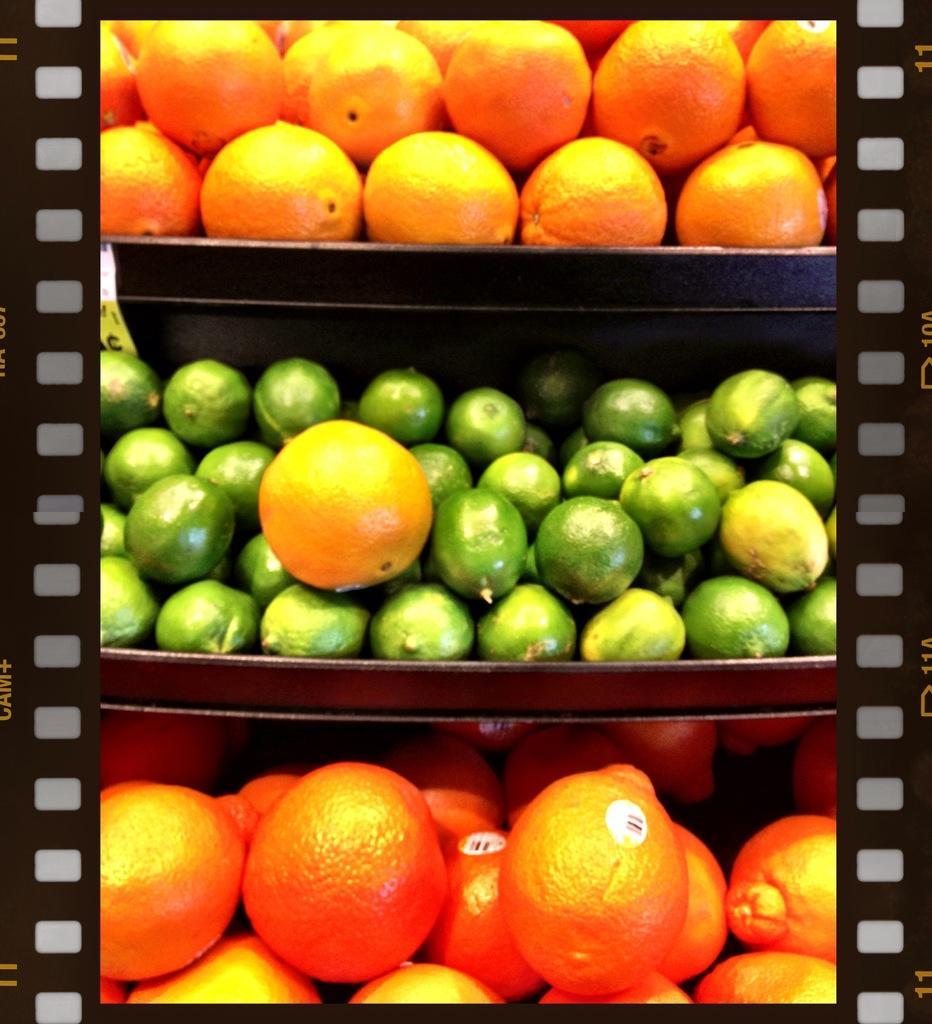Can you describe this image briefly? This is an edited image. In this image we can see the fruits in shelves. 